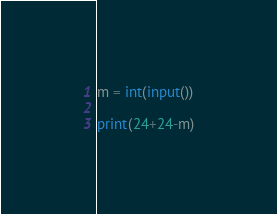Convert code to text. <code><loc_0><loc_0><loc_500><loc_500><_Python_>m = int(input())

print(24+24-m)</code> 